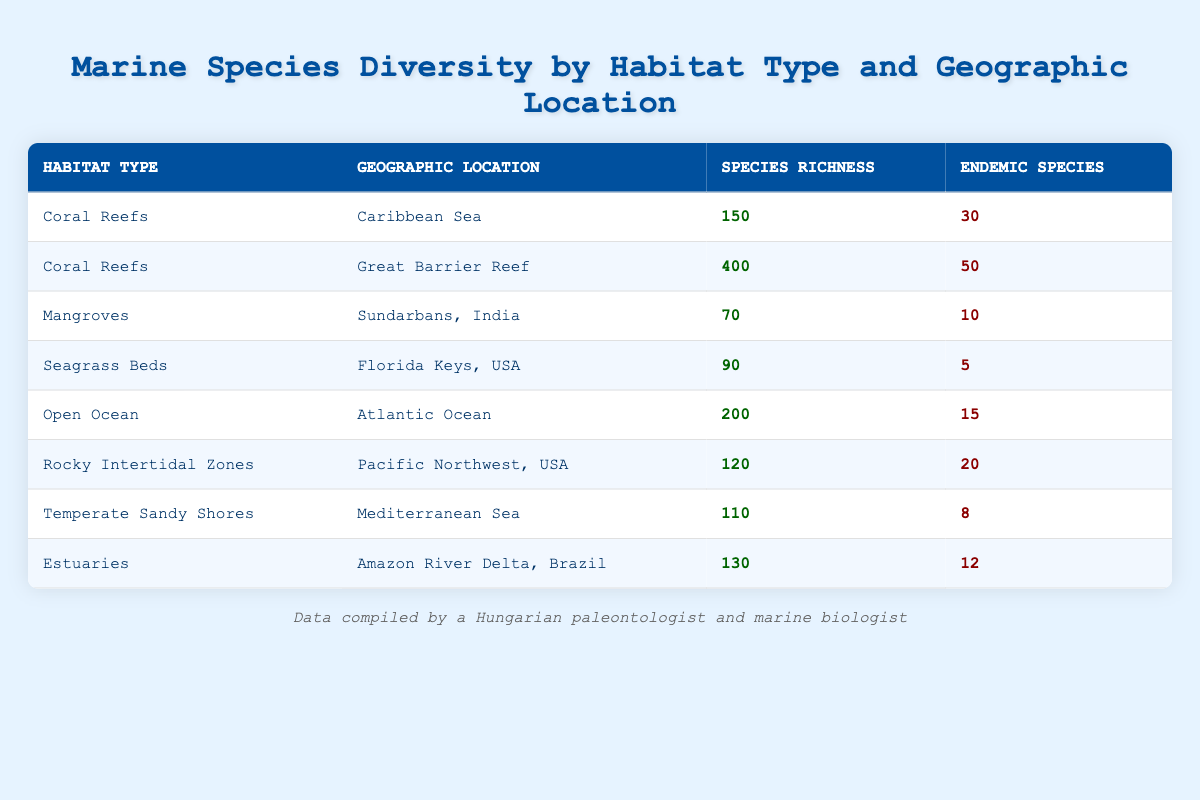What is the species richness in the Great Barrier Reef? The table lists the species richness for the Great Barrier Reef under the Coral Reefs habitat type, which shows a value of 400.
Answer: 400 Which habitat type has the highest number of endemic species? By examining the table, the Great Barrier Reef has 50 endemic species, which is the highest number compared to other habitats.
Answer: 50 How many species are found in the Coral Reefs overall? The table lists two entries for Coral Reefs: 150 species in the Caribbean Sea and 400 species in the Great Barrier Reef. Summing these gives 150 + 400 = 550 species in total.
Answer: 550 Is the number of endemic species in the Pacific Northwest higher than in the Florida Keys? In the table, the Pacific Northwest has 20 endemic species while the Florida Keys has 5 endemic species. Since 20 is greater than 5, this statement is true.
Answer: Yes What is the average species richness across all listed habitat types? The species richness values are: 150, 400, 70, 90, 200, 120, 110, and 130. Adding these gives a total of 1,270 species. There are 8 habitat types, so average = 1,270 / 8 = 158.75.
Answer: 158.75 Which geographic location has the lowest species richness and what is its value? By examining the table, the habitat with the lowest species richness is the Sundarbans, India, with 70 species.
Answer: 70 Are there any habitats in the table with more endemic species than the average number of endemic species across all habitats? First, we find the average number of endemic species: (30 + 50 + 10 + 5 + 15 + 20 + 8 + 12) = 150, then 150 / 8 = 18.75. The Great Barrier Reef (50) and Pacific Northwest (20) both have more endemic species than 18.75.
Answer: Yes What is the difference in species richness between the Open Ocean and Estuaries? The species richness for the Open Ocean is 200 and for Estuaries it is 130. The difference is 200 - 130 = 70.
Answer: 70 